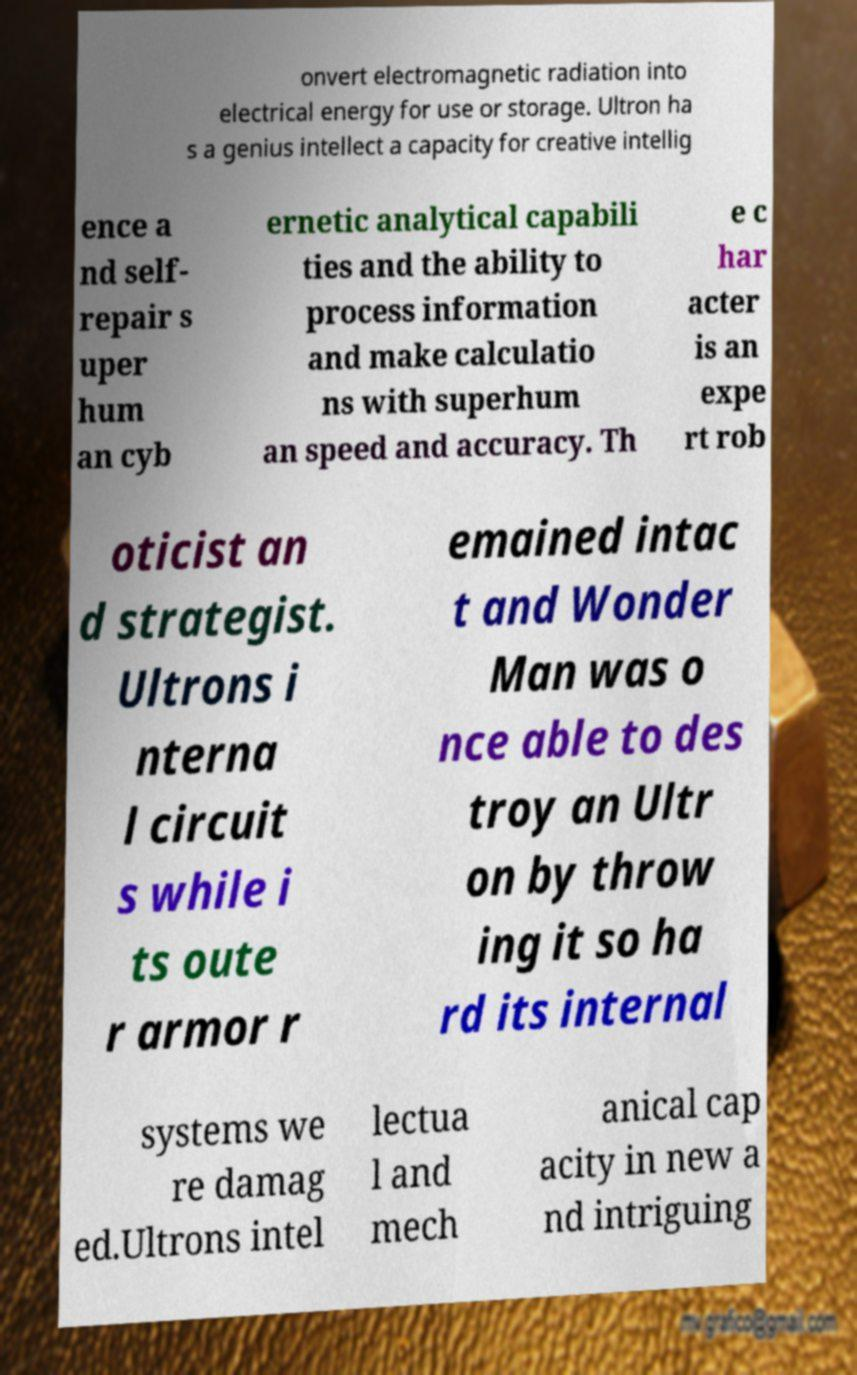Can you read and provide the text displayed in the image?This photo seems to have some interesting text. Can you extract and type it out for me? onvert electromagnetic radiation into electrical energy for use or storage. Ultron ha s a genius intellect a capacity for creative intellig ence a nd self- repair s uper hum an cyb ernetic analytical capabili ties and the ability to process information and make calculatio ns with superhum an speed and accuracy. Th e c har acter is an expe rt rob oticist an d strategist. Ultrons i nterna l circuit s while i ts oute r armor r emained intac t and Wonder Man was o nce able to des troy an Ultr on by throw ing it so ha rd its internal systems we re damag ed.Ultrons intel lectua l and mech anical cap acity in new a nd intriguing 